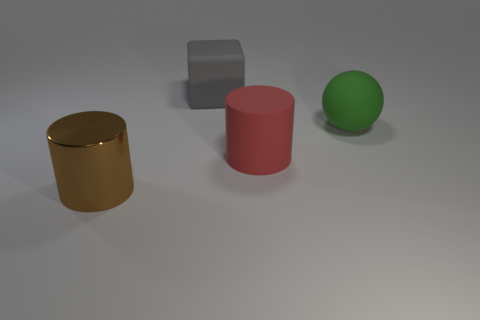There is a matte object that is to the left of the big cylinder behind the brown metallic cylinder; what color is it?
Keep it short and to the point. Gray. Are there any large cyan matte blocks?
Your answer should be very brief. No. Is the shape of the big green thing the same as the large red thing?
Your answer should be compact. No. What number of gray matte cubes are in front of the cylinder that is in front of the big red rubber thing?
Give a very brief answer. 0. How many objects are both left of the big gray block and right of the red matte cylinder?
Ensure brevity in your answer.  0. How many objects are cylinders or cylinders to the left of the matte cylinder?
Ensure brevity in your answer.  2. There is a green object that is the same material as the red object; what size is it?
Your answer should be very brief. Large. There is a big matte thing behind the large rubber object to the right of the red cylinder; what shape is it?
Ensure brevity in your answer.  Cube. What number of gray objects are either cylinders or large matte spheres?
Provide a succinct answer. 0. Is there a matte sphere behind the thing that is behind the matte object that is to the right of the red matte cylinder?
Provide a succinct answer. No. 